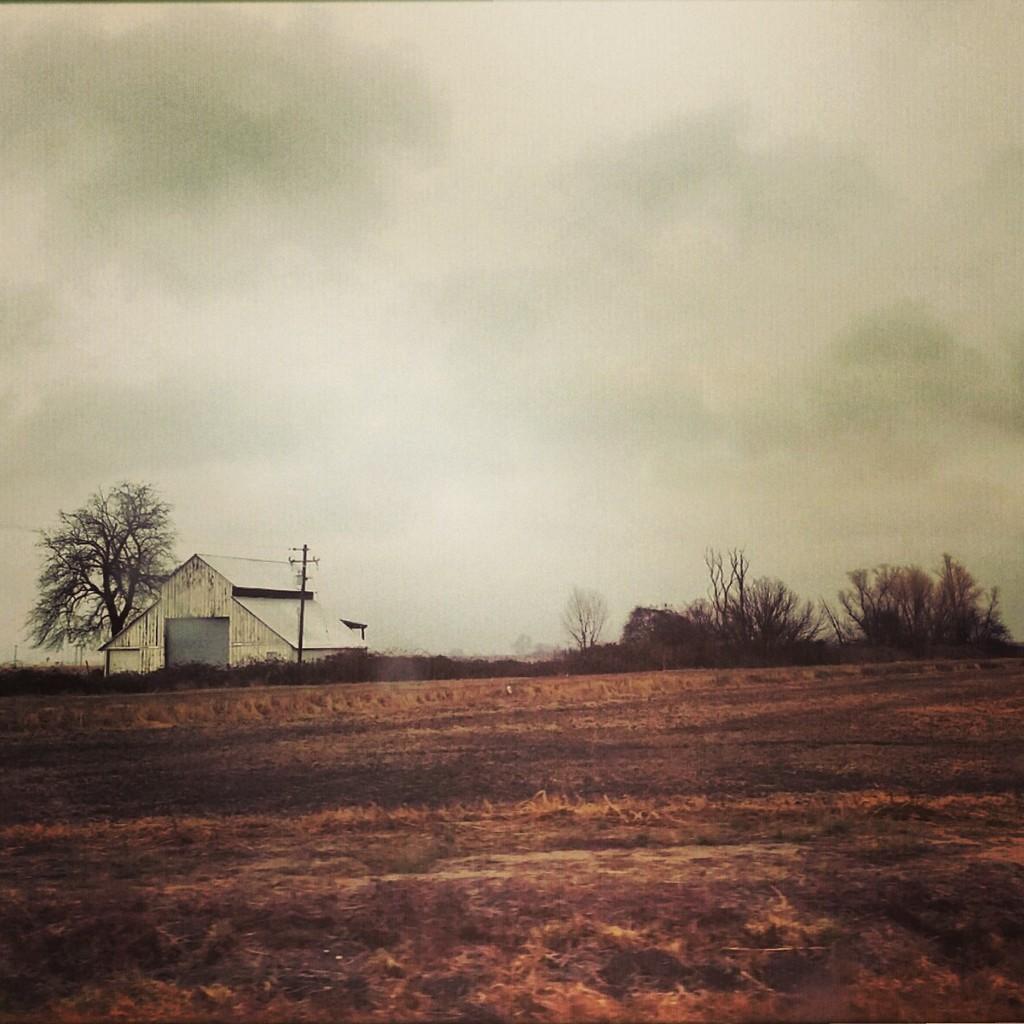Describe this image in one or two sentences. In this image I can see grass, trees, fence, house, light pole and the sky. This image is taken may be on the ground. 